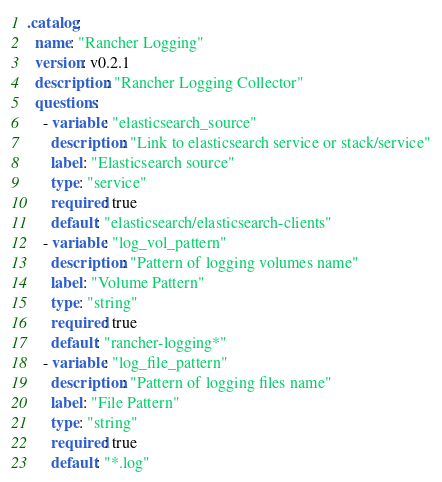<code> <loc_0><loc_0><loc_500><loc_500><_YAML_>.catalog:
  name: "Rancher Logging"
  version: v0.2.1
  description: "Rancher Logging Collector"
  questions:
    - variable: "elasticsearch_source"
      description: "Link to elasticsearch service or stack/service"
      label: "Elasticsearch source"
      type: "service"
      required: true
      default: "elasticsearch/elasticsearch-clients"
    - variable: "log_vol_pattern"
      description: "Pattern of logging volumes name"
      label: "Volume Pattern"
      type: "string"
      required: true
      default: "rancher-logging*"
    - variable: "log_file_pattern"
      description: "Pattern of logging files name"
      label: "File Pattern"
      type: "string"
      required: true
      default: "*.log"
</code> 